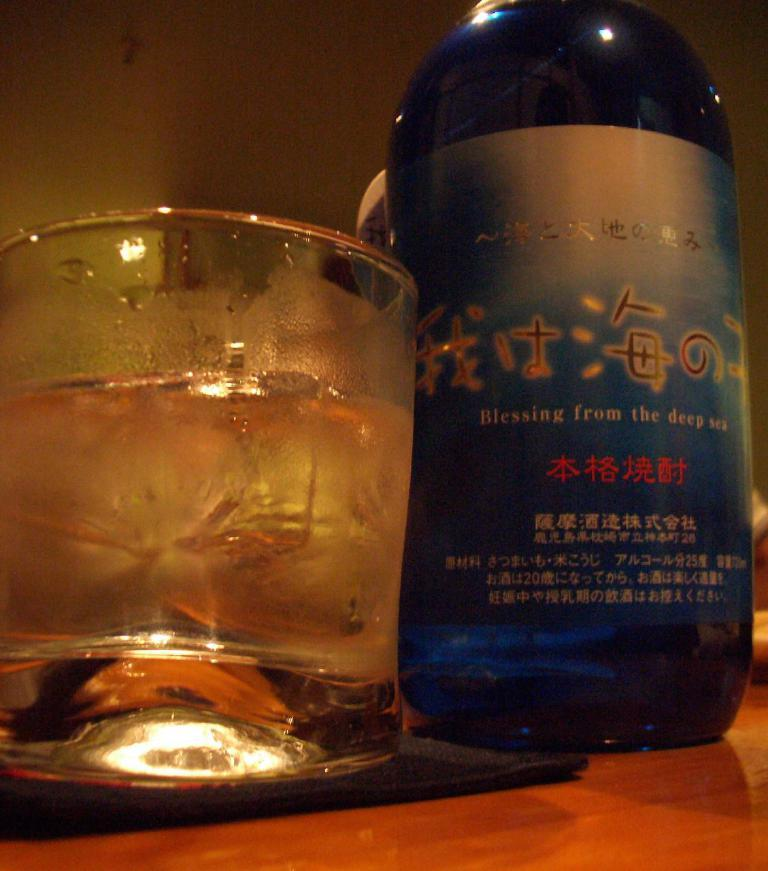<image>
Render a clear and concise summary of the photo. Blue bottle of alcohol that says "Blessing from the Deep Sea" on the label. 